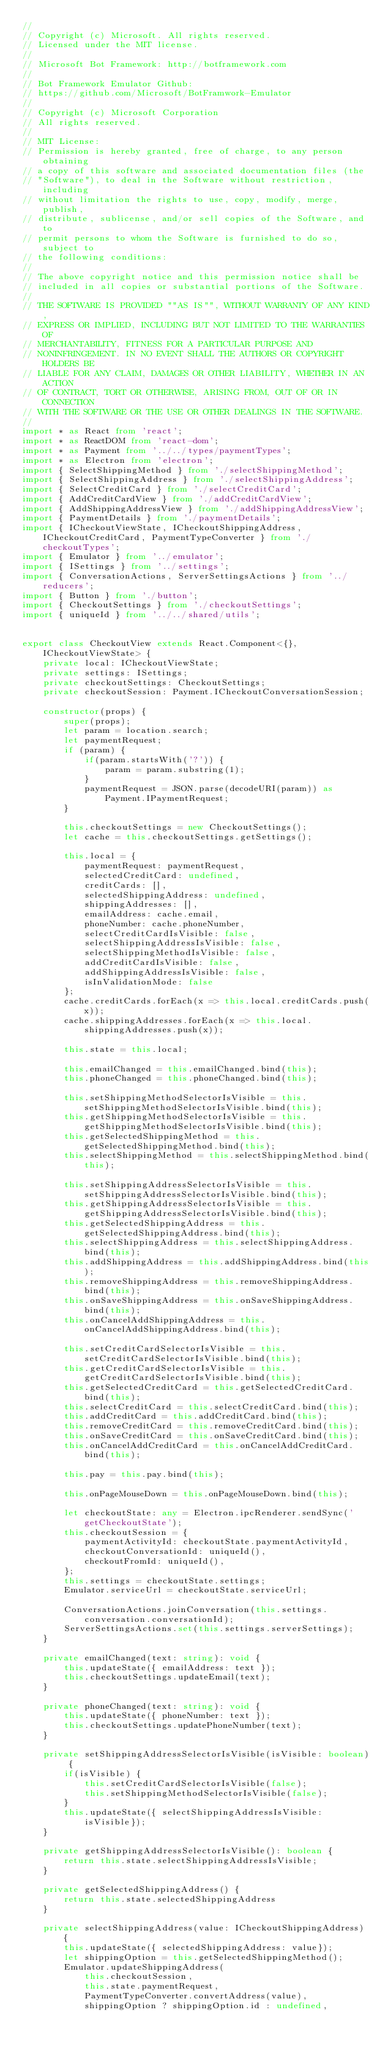Convert code to text. <code><loc_0><loc_0><loc_500><loc_500><_TypeScript_>//
// Copyright (c) Microsoft. All rights reserved.
// Licensed under the MIT license.
//
// Microsoft Bot Framework: http://botframework.com
//
// Bot Framework Emulator Github:
// https://github.com/Microsoft/BotFramwork-Emulator
//
// Copyright (c) Microsoft Corporation
// All rights reserved.
//
// MIT License:
// Permission is hereby granted, free of charge, to any person obtaining
// a copy of this software and associated documentation files (the
// "Software"), to deal in the Software without restriction, including
// without limitation the rights to use, copy, modify, merge, publish,
// distribute, sublicense, and/or sell copies of the Software, and to
// permit persons to whom the Software is furnished to do so, subject to
// the following conditions:
//
// The above copyright notice and this permission notice shall be
// included in all copies or substantial portions of the Software.
//
// THE SOFTWARE IS PROVIDED ""AS IS"", WITHOUT WARRANTY OF ANY KIND,
// EXPRESS OR IMPLIED, INCLUDING BUT NOT LIMITED TO THE WARRANTIES OF
// MERCHANTABILITY, FITNESS FOR A PARTICULAR PURPOSE AND
// NONINFRINGEMENT. IN NO EVENT SHALL THE AUTHORS OR COPYRIGHT HOLDERS BE
// LIABLE FOR ANY CLAIM, DAMAGES OR OTHER LIABILITY, WHETHER IN AN ACTION
// OF CONTRACT, TORT OR OTHERWISE, ARISING FROM, OUT OF OR IN CONNECTION
// WITH THE SOFTWARE OR THE USE OR OTHER DEALINGS IN THE SOFTWARE.
//
import * as React from 'react';
import * as ReactDOM from 'react-dom';
import * as Payment from '../../types/paymentTypes';
import * as Electron from 'electron';
import { SelectShippingMethod } from './selectShippingMethod';
import { SelectShippingAddress } from './selectShippingAddress';
import { SelectCreditCard } from './selectCreditCard';
import { AddCreditCardView } from './addCreditCardView';
import { AddShippingAddressView } from './addShippingAddressView';
import { PaymentDetails } from './paymentDetails';
import { ICheckoutViewState, ICheckoutShippingAddress, ICheckoutCreditCard, PaymentTypeConverter } from './checkoutTypes';
import { Emulator } from '../emulator';
import { ISettings } from '../settings';
import { ConversationActions, ServerSettingsActions } from '../reducers';
import { Button } from './button';
import { CheckoutSettings } from './checkoutSettings';
import { uniqueId } from '../../shared/utils';


export class CheckoutView extends React.Component<{}, ICheckoutViewState> {
    private local: ICheckoutViewState;
    private settings: ISettings;
    private checkoutSettings: CheckoutSettings;
    private checkoutSession: Payment.ICheckoutConversationSession;

    constructor(props) {
        super(props);
        let param = location.search;
        let paymentRequest;
        if (param) {
            if(param.startsWith('?')) {
                param = param.substring(1);
            }
            paymentRequest = JSON.parse(decodeURI(param)) as Payment.IPaymentRequest;
        }

        this.checkoutSettings = new CheckoutSettings();
        let cache = this.checkoutSettings.getSettings();

        this.local = {
            paymentRequest: paymentRequest,
            selectedCreditCard: undefined,
            creditCards: [],
            selectedShippingAddress: undefined,
            shippingAddresses: [],
            emailAddress: cache.email,
            phoneNumber: cache.phoneNumber,
            selectCreditCardIsVisible: false,
            selectShippingAddressIsVisible: false,
            selectShippingMethodIsVisible: false,
            addCreditCardIsVisible: false,
            addShippingAddressIsVisible: false,
            isInValidationMode: false
        };
        cache.creditCards.forEach(x => this.local.creditCards.push(x));
        cache.shippingAddresses.forEach(x => this.local.shippingAddresses.push(x));

        this.state = this.local;

        this.emailChanged = this.emailChanged.bind(this);
        this.phoneChanged = this.phoneChanged.bind(this);

        this.setShippingMethodSelectorIsVisible = this.setShippingMethodSelectorIsVisible.bind(this);
        this.getShippingMethodSelectorIsVisible = this.getShippingMethodSelectorIsVisible.bind(this);
        this.getSelectedShippingMethod = this.getSelectedShippingMethod.bind(this);
        this.selectShippingMethod = this.selectShippingMethod.bind(this);

        this.setShippingAddressSelectorIsVisible = this.setShippingAddressSelectorIsVisible.bind(this);
        this.getShippingAddressSelectorIsVisible = this.getShippingAddressSelectorIsVisible.bind(this);
        this.getSelectedShippingAddress = this.getSelectedShippingAddress.bind(this);
        this.selectShippingAddress = this.selectShippingAddress.bind(this);
        this.addShippingAddress = this.addShippingAddress.bind(this);
        this.removeShippingAddress = this.removeShippingAddress.bind(this);
        this.onSaveShippingAddress = this.onSaveShippingAddress.bind(this);
        this.onCancelAddShippingAddress = this.onCancelAddShippingAddress.bind(this);

        this.setCreditCardSelectorIsVisible = this.setCreditCardSelectorIsVisible.bind(this);
        this.getCreditCardSelectorIsVisible = this.getCreditCardSelectorIsVisible.bind(this);
        this.getSelectedCreditCard = this.getSelectedCreditCard.bind(this);
        this.selectCreditCard = this.selectCreditCard.bind(this);
        this.addCreditCard = this.addCreditCard.bind(this);
        this.removeCreditCard = this.removeCreditCard.bind(this);
        this.onSaveCreditCard = this.onSaveCreditCard.bind(this);
        this.onCancelAddCreditCard = this.onCancelAddCreditCard.bind(this);

        this.pay = this.pay.bind(this);

        this.onPageMouseDown = this.onPageMouseDown.bind(this);

        let checkoutState: any = Electron.ipcRenderer.sendSync('getCheckoutState');
        this.checkoutSession = {
            paymentActivityId: checkoutState.paymentActivityId,
            checkoutConversationId: uniqueId(),
            checkoutFromId: uniqueId(),
        };
        this.settings = checkoutState.settings;
        Emulator.serviceUrl = checkoutState.serviceUrl;

        ConversationActions.joinConversation(this.settings.conversation.conversationId);
        ServerSettingsActions.set(this.settings.serverSettings);
    }

    private emailChanged(text: string): void {
        this.updateState({ emailAddress: text });
        this.checkoutSettings.updateEmail(text);
    }

    private phoneChanged(text: string): void {
        this.updateState({ phoneNumber: text });
        this.checkoutSettings.updatePhoneNumber(text);
    }

    private setShippingAddressSelectorIsVisible(isVisible: boolean) {
        if(isVisible) {
            this.setCreditCardSelectorIsVisible(false);
            this.setShippingMethodSelectorIsVisible(false);
        }
        this.updateState({ selectShippingAddressIsVisible: isVisible});
    }

    private getShippingAddressSelectorIsVisible(): boolean {
        return this.state.selectShippingAddressIsVisible;
    }

    private getSelectedShippingAddress() {
        return this.state.selectedShippingAddress
    }

    private selectShippingAddress(value: ICheckoutShippingAddress) {
        this.updateState({ selectedShippingAddress: value});
        let shippingOption = this.getSelectedShippingMethod();
        Emulator.updateShippingAddress(
            this.checkoutSession,
            this.state.paymentRequest,
            PaymentTypeConverter.convertAddress(value),
            shippingOption ? shippingOption.id : undefined,</code> 